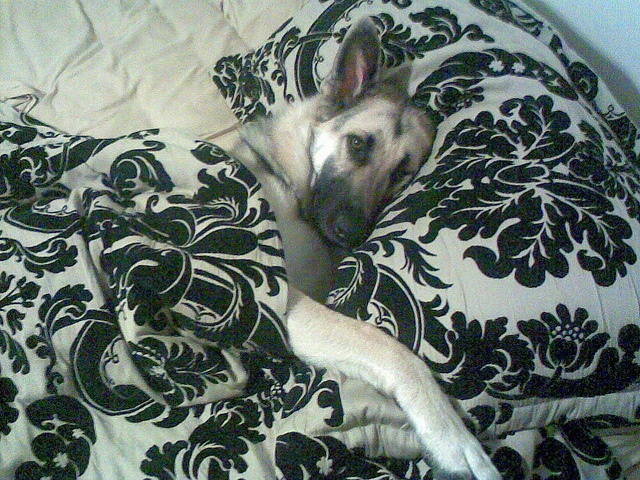Describe the objects in this image and their specific colors. I can see bed in black, lightgray, darkgray, and gray tones and dog in beige, ivory, gray, darkgray, and black tones in this image. 